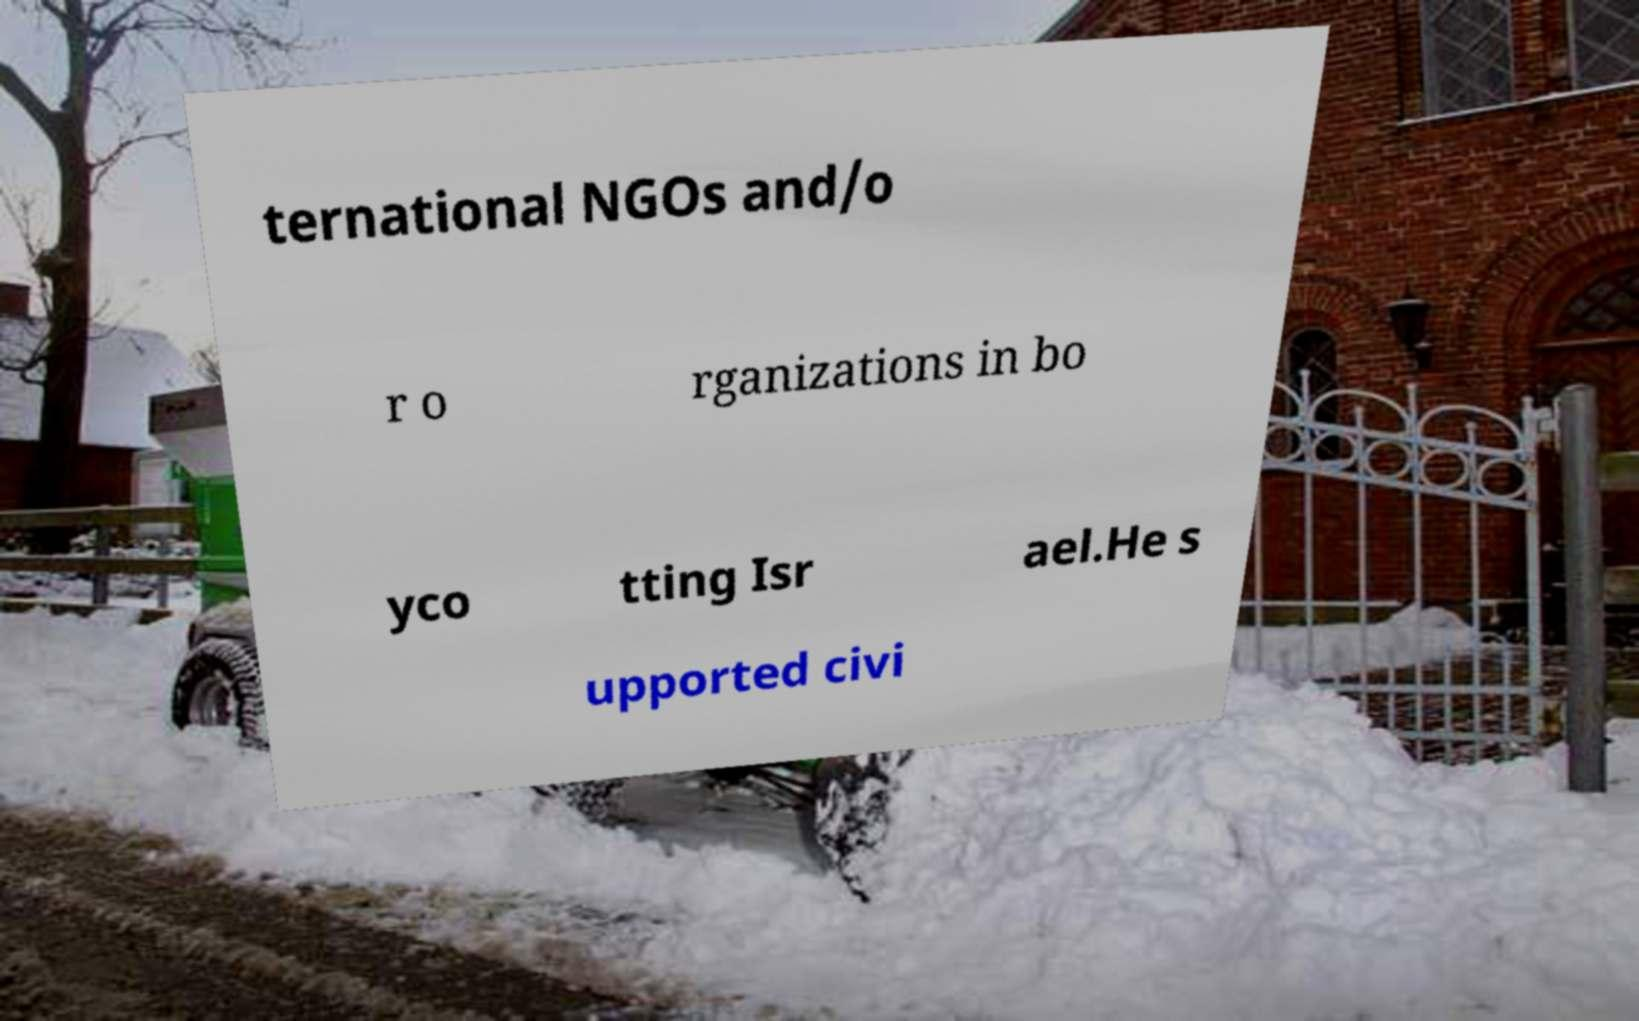What messages or text are displayed in this image? I need them in a readable, typed format. ternational NGOs and/o r o rganizations in bo yco tting Isr ael.He s upported civi 